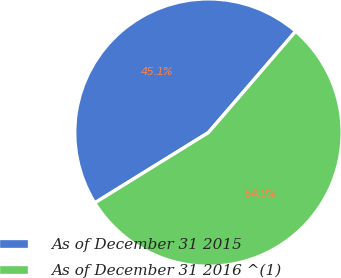Convert chart to OTSL. <chart><loc_0><loc_0><loc_500><loc_500><pie_chart><fcel>As of December 31 2015<fcel>As of December 31 2016 ^(1)<nl><fcel>45.14%<fcel>54.86%<nl></chart> 